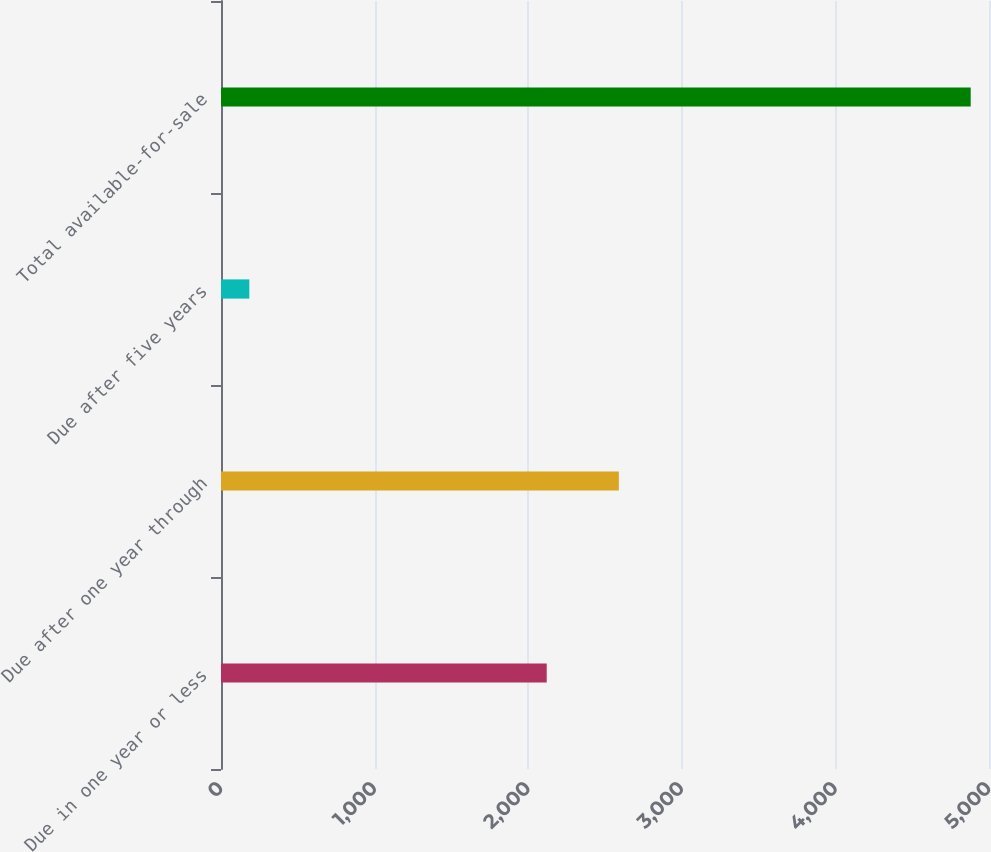Convert chart. <chart><loc_0><loc_0><loc_500><loc_500><bar_chart><fcel>Due in one year or less<fcel>Due after one year through<fcel>Due after five years<fcel>Total available-for-sale<nl><fcel>2120.5<fcel>2590.14<fcel>184.5<fcel>4880.9<nl></chart> 